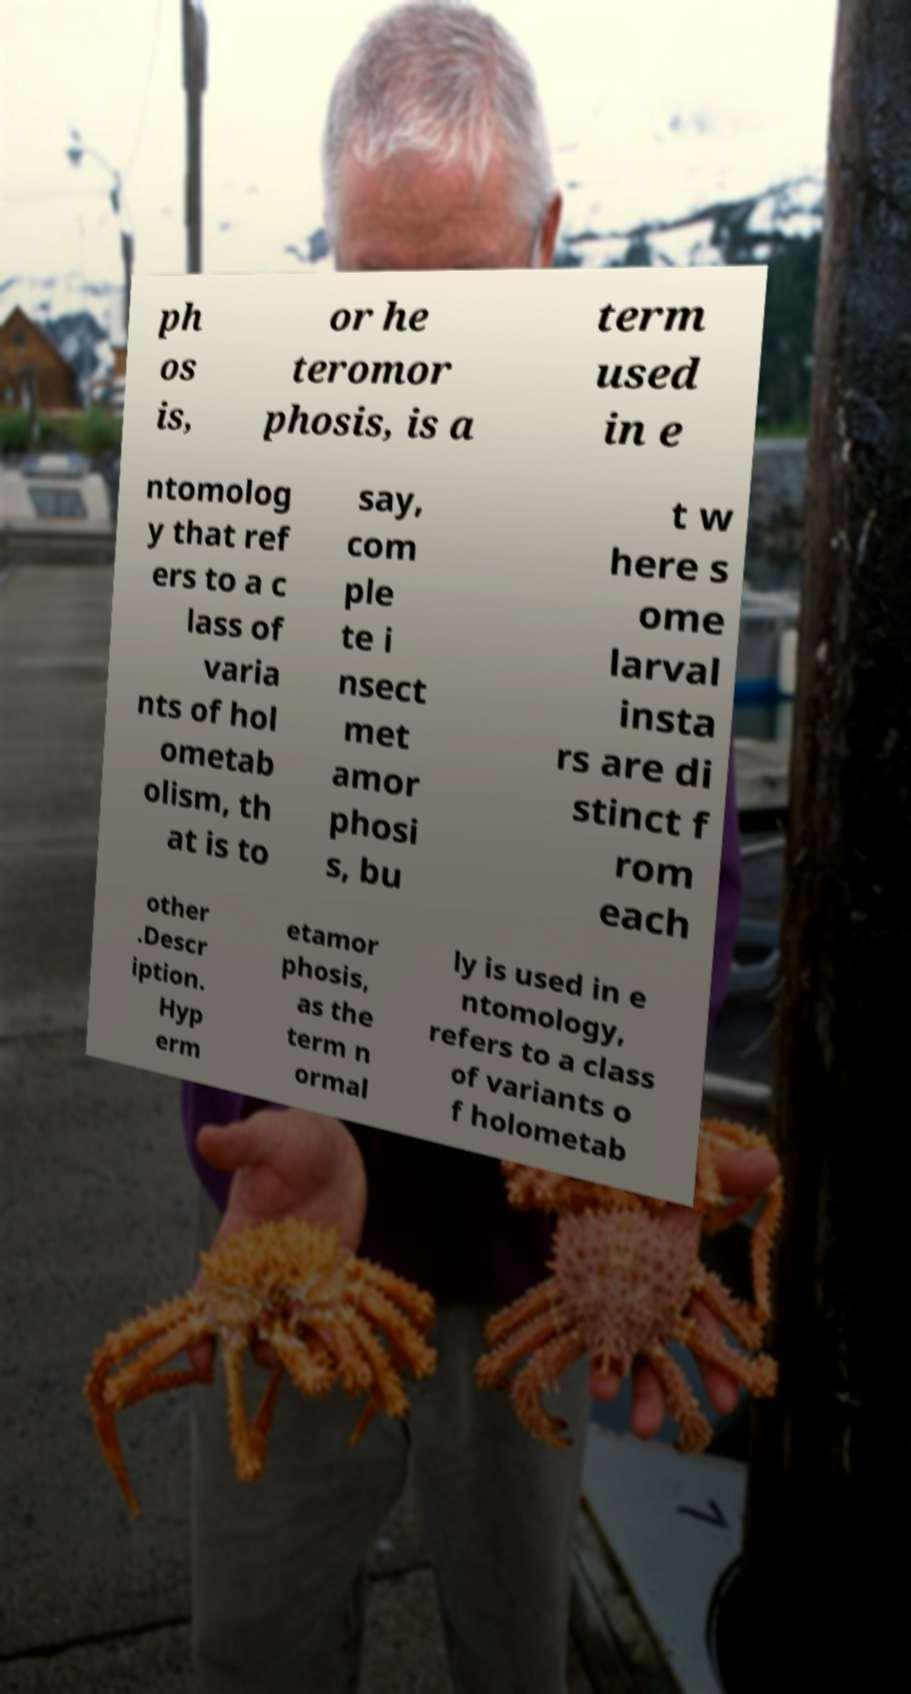Can you accurately transcribe the text from the provided image for me? ph os is, or he teromor phosis, is a term used in e ntomolog y that ref ers to a c lass of varia nts of hol ometab olism, th at is to say, com ple te i nsect met amor phosi s, bu t w here s ome larval insta rs are di stinct f rom each other .Descr iption. Hyp erm etamor phosis, as the term n ormal ly is used in e ntomology, refers to a class of variants o f holometab 